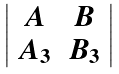<formula> <loc_0><loc_0><loc_500><loc_500>\left | \begin{array} { c c } A & B \\ A _ { 3 } & B _ { 3 } \end{array} \right |</formula> 